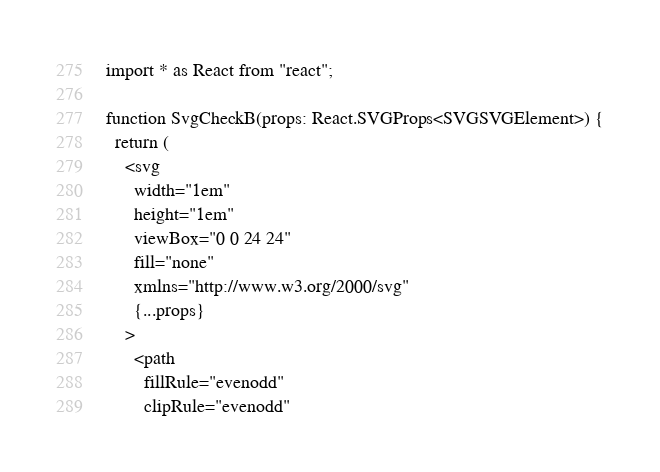Convert code to text. <code><loc_0><loc_0><loc_500><loc_500><_TypeScript_>import * as React from "react";

function SvgCheckB(props: React.SVGProps<SVGSVGElement>) {
  return (
    <svg
      width="1em"
      height="1em"
      viewBox="0 0 24 24"
      fill="none"
      xmlns="http://www.w3.org/2000/svg"
      {...props}
    >
      <path
        fillRule="evenodd"
        clipRule="evenodd"</code> 